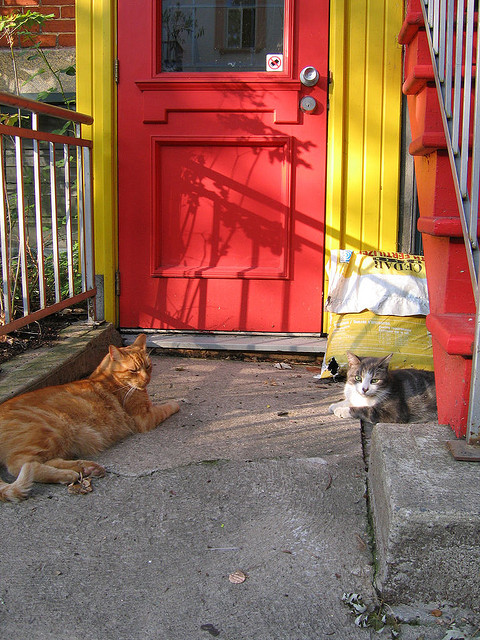Please transcribe the text in this image. CEDAR 